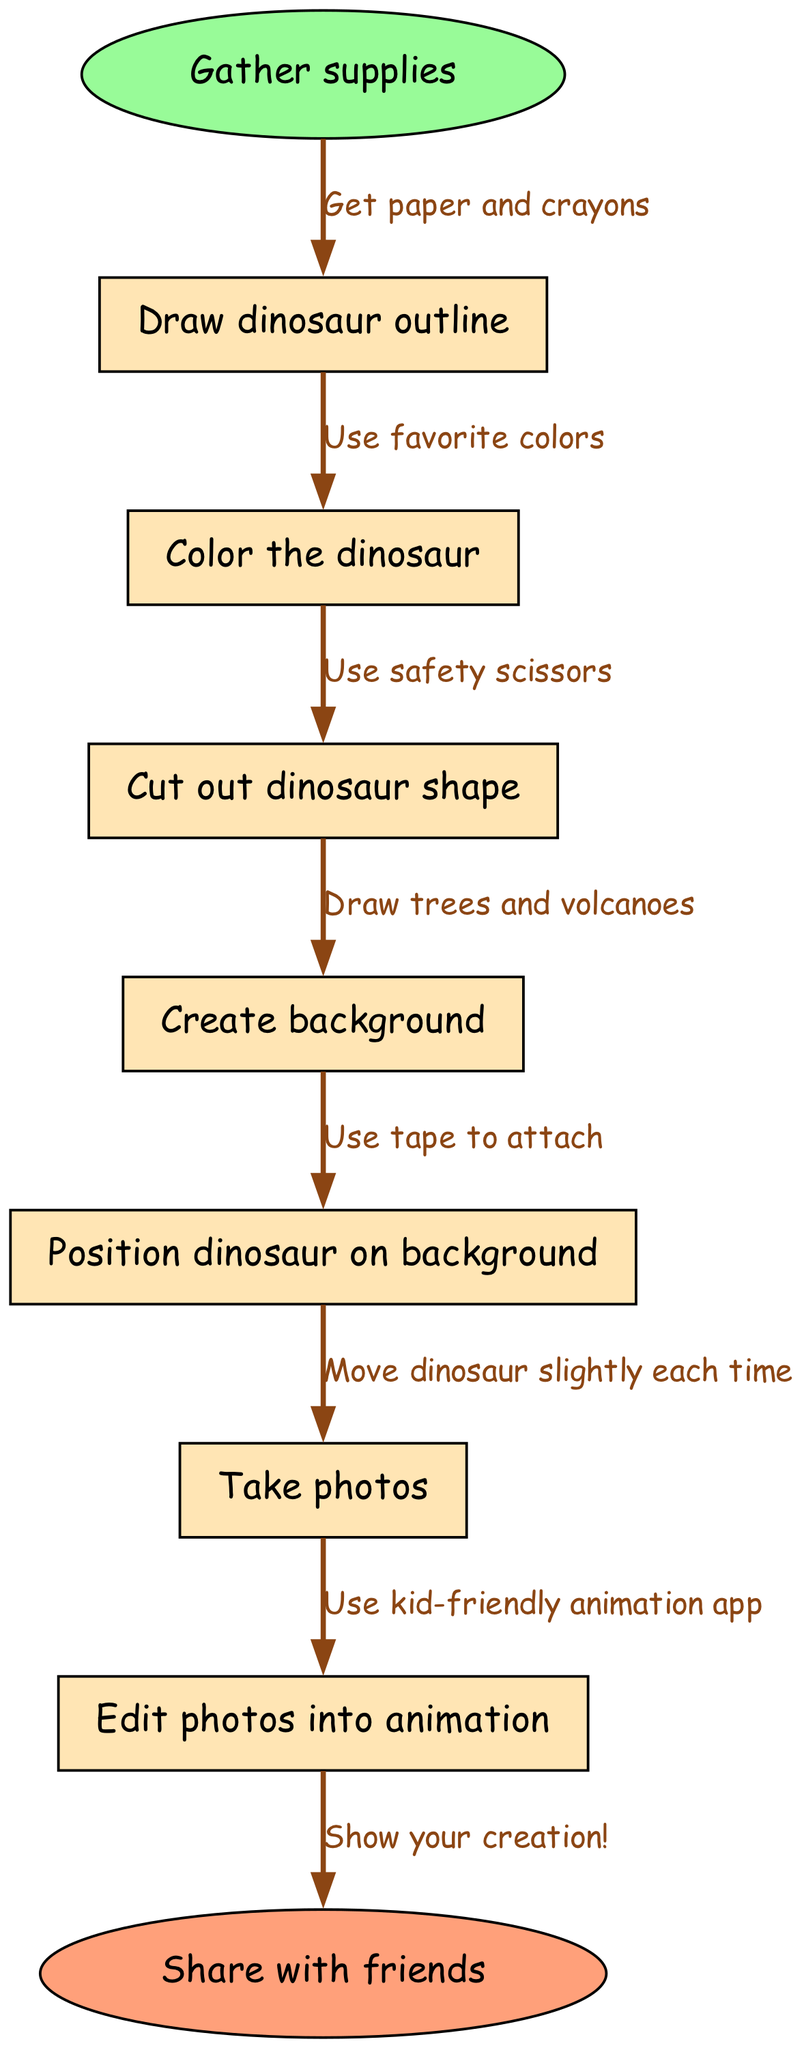What is the first step in the animation process? The diagram starts with the node labeled "Gather supplies," indicating this is the first step in the process.
Answer: Gather supplies How many nodes are in the diagram? The diagram contains eight nodes in total: one start node, six intermediate nodes, and one end node.
Answer: Eight What is the last action before sharing the animation? The last action before sharing the animation is "Edit photos into animation," which is the last intermediate step before reaching the end node.
Answer: Edit photos into animation What materials do you need to gather? The edge from the start node specifies that you need to "Get paper and crayons" as supplies, which is the first action you should take.
Answer: Paper and crayons Which step involves creating the scene for the dinosaur? The step titled "Create background" directly addresses making the setting where the dinosaur will be positioned, indicating that this is when the scene is created.
Answer: Create background What is used to attach the dinosaur to the background? The edge connecting the node "Position dinosaur on background" indicates that "Use tape to attach" the dinosaur to the created background.
Answer: Tape What colors should be used to color the dinosaur? The edge leading to the node "Color the dinosaur" mentions using your "favorite colors" when coloring the dinosaur, which should reflect personal preference.
Answer: Favorite colors How does the dinosaur move in the animation? According to the edge from "Take photos" to the next step, it says to "Move dinosaur slightly each time," indicating this is how the animation will be created.
Answer: Slightly each time What is the final outcome once all steps are completed? The final node indicates the outcome is to "Share with friends," which is the final action taken after completing the animation process.
Answer: Share with friends 